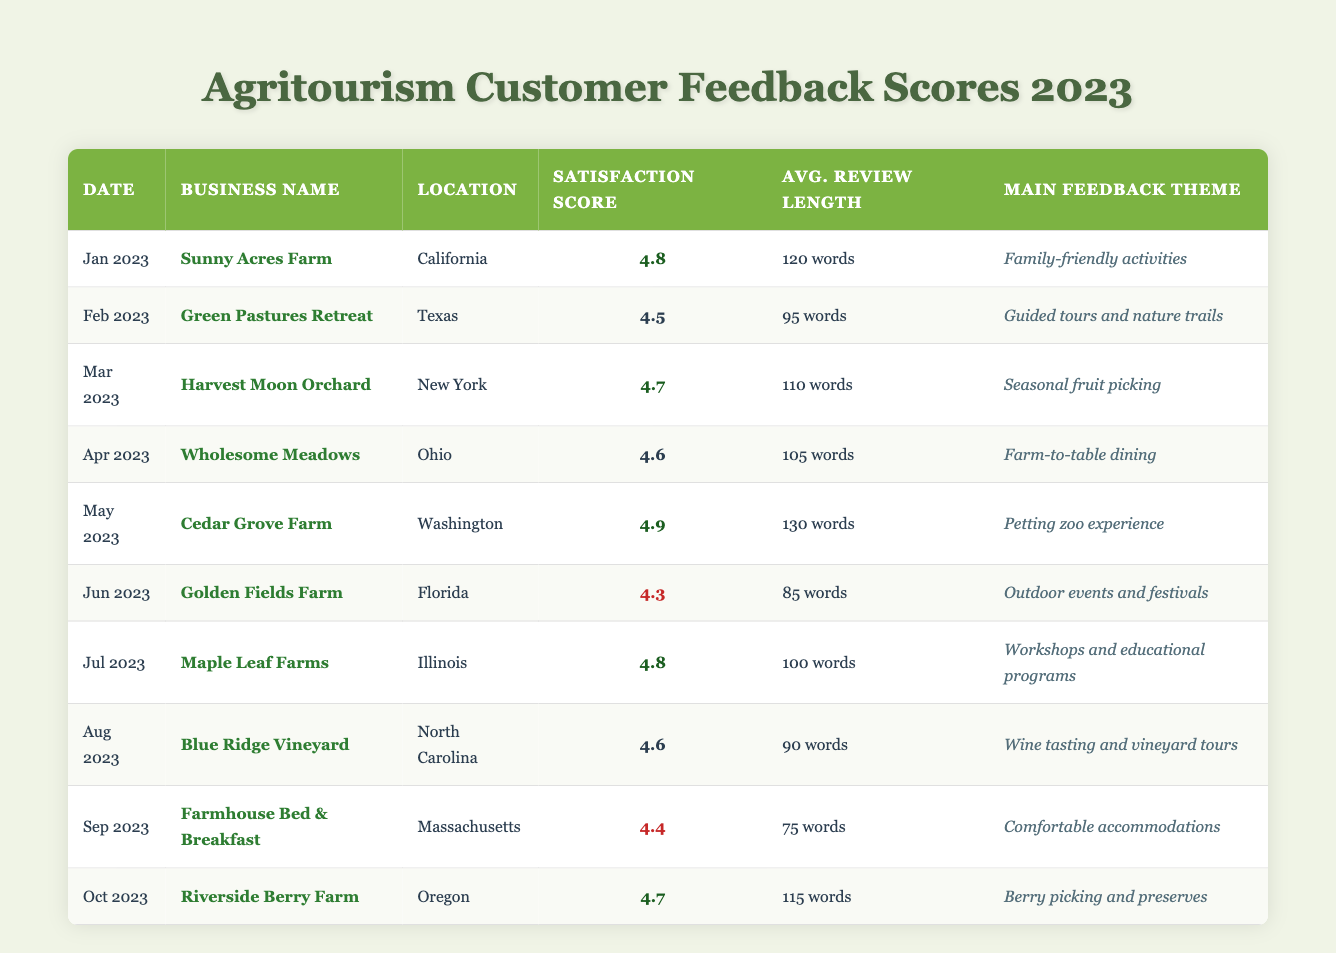What was the customer satisfaction score for Cedar Grove Farm in May 2023? Cedar Grove Farm's customer satisfaction score is listed as 4.9 in the table under May 2023.
Answer: 4.9 Which agritourism business had the lowest customer satisfaction score in June 2023? Golden Fields Farm had the lowest customer satisfaction score in June 2023 with a score of 4.3, as noted in the respective row for that month.
Answer: Golden Fields Farm What is the average customer satisfaction score for the businesses listed from January to April 2023? The scores for January to April are 4.8, 4.5, 4.7, and 4.6. Adding these scores gives 4.8 + 4.5 + 4.7 + 4.6 = 19.6. Dividing by 4 (the number of months) provides an average of 19.6 / 4 = 4.9.
Answer: 4.9 Did any business score above 4.7 for customer satisfaction in 2023? Yes, Cedar Grove Farm scored 4.9 in May 2023, and also Sunny Acres Farm scored 4.8 in January 2023, both above 4.7.
Answer: Yes How many businesses had an average review length greater than 100 words? The review lengths greater than 100 words are: Sunny Acres Farm (120), Harvest Moon Orchard (110), Cedar Grove Farm (130), and Riverside Berry Farm (115). There are 4 businesses with lengths over 100 words.
Answer: 4 Which month saw the highest customer satisfaction score and what was the score? In May 2023, Cedar Grove Farm achieved the highest customer satisfaction score of 4.9.
Answer: May 2023, 4.9 What was the main feedback theme for the business in Oregon for October 2023? The main feedback theme for Riverside Berry Farm in Oregon for October 2023 is berry picking and preserves, as shown in the respective row.
Answer: Berry picking and preserves What was the difference in customer satisfaction scores between the highest (Cedar Grove Farm) and the lowest (Golden Fields Farm) in 2023? Cedar Grove Farm scored 4.9 while Golden Fields Farm scored 4.3. The difference is 4.9 - 4.3 = 0.6.
Answer: 0.6 Which business had the main theme of "Workshops and educational programs," and what was their score? Maple Leaf Farms was associated with "Workshops and educational programs" and had a score of 4.8, as per the table entry for July 2023.
Answer: Maple Leaf Farms, 4.8 Is there a business that received a customer satisfaction score lower than 4.4? Yes, Golden Fields Farm scored 4.3 in June 2023, which is lower than 4.4.
Answer: Yes 